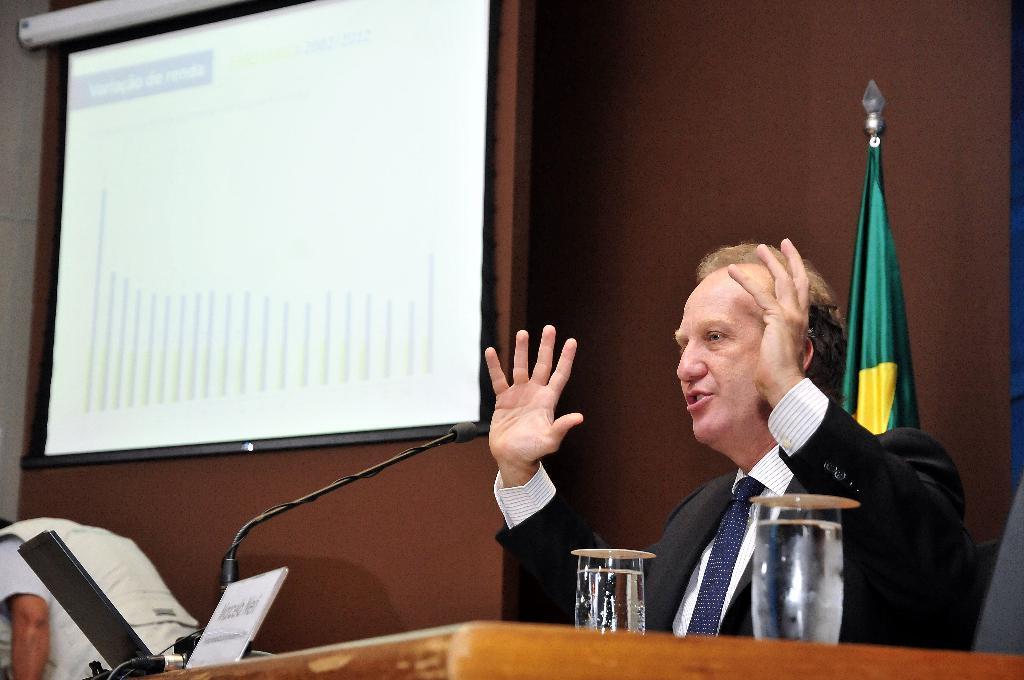Can you describe this image briefly? In the front of the image we can see a person and table. Above the table there is a name board, mic, glasses, laptop and cables. In the background we can see wall, screen, person and flag. 